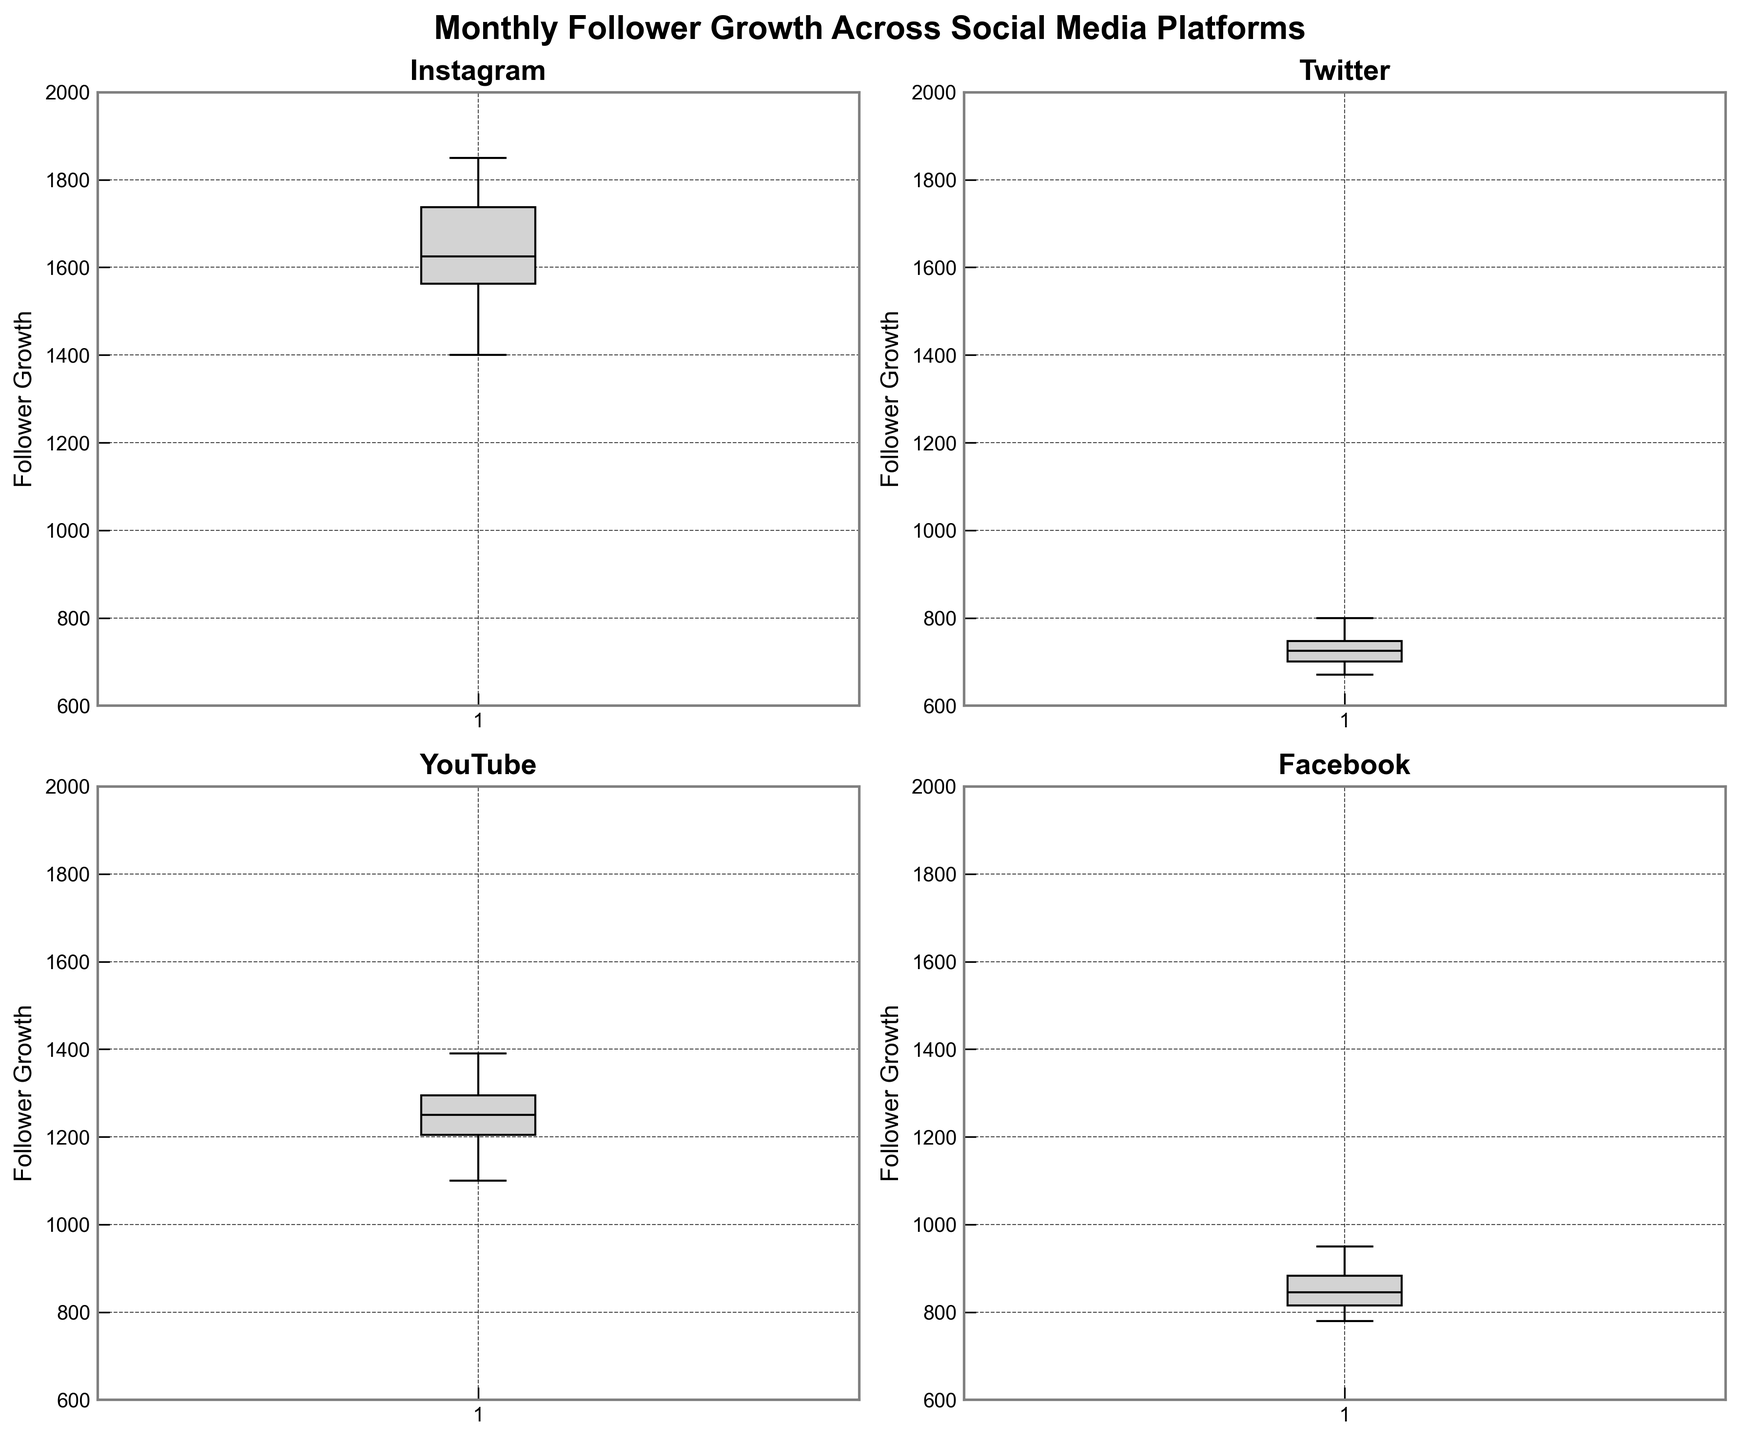Which platform shows the highest median follower growth? The plot for each platform indicates the median by a horizontal line within the box. Instagram's median line is the highest among the four platforms.
Answer: Instagram Which platform has the most consistent (least variable) follower growth? Consistency in growth can be interpreted by the range between the upper and lower whiskers of the box plot. Facebook has the shortest spread, indicating the least variability.
Answer: Facebook What is the approximate range of follower growth for Twitter? The range in a box plot is indicated by the difference between the minimum and maximum values (lower and upper whiskers). For Twitter, this is approximately from 670 to 800.
Answer: 670 to 800 How does the follower growth of YouTube in May compare to that of Facebook in May? To compare, observe the position of the top edges of the boxes. YouTube's box for follower growth in May extends higher than Facebook's, indicating higher growth for YouTube.
Answer: YouTube had higher growth What is the shape of the distribution for Instagram follower growth? The shape can be seen by the spatial relations of the box components. Instagram shows a fairly symmetrical box with whiskers, indicating a more normally distributed growth with no extreme skew.
Answer: Symmetrical Is there any month where all platforms experienced a decline in follower growth? Note periods of decrease by observing the consistency of each month's data. March shows a decline in follower growth across all platforms compared to February.
Answer: March Which month shows the biggest difference in follower growth between Instagram and Twitter? Calculate the differences in the follower growth between Instagram and Twitter for each month and identify the largest difference. The biggest difference appears in August.
Answer: August Does any platform show outliers? Outliers in box plots appear as points outside the whiskers. None of the platforms show marked outliers beyond the whiskers in the given plots.
Answer: No What's the visual difference between the follower growth distributions of Instagram and Twitter? Instagram's box plot shows a taller and more symmetric box compared to Twitter's shorter and slightly skewed box plot, indicating Instagram has higher and more varied growth than Twitter.
Answer: Instagram has higher and more varied growth 